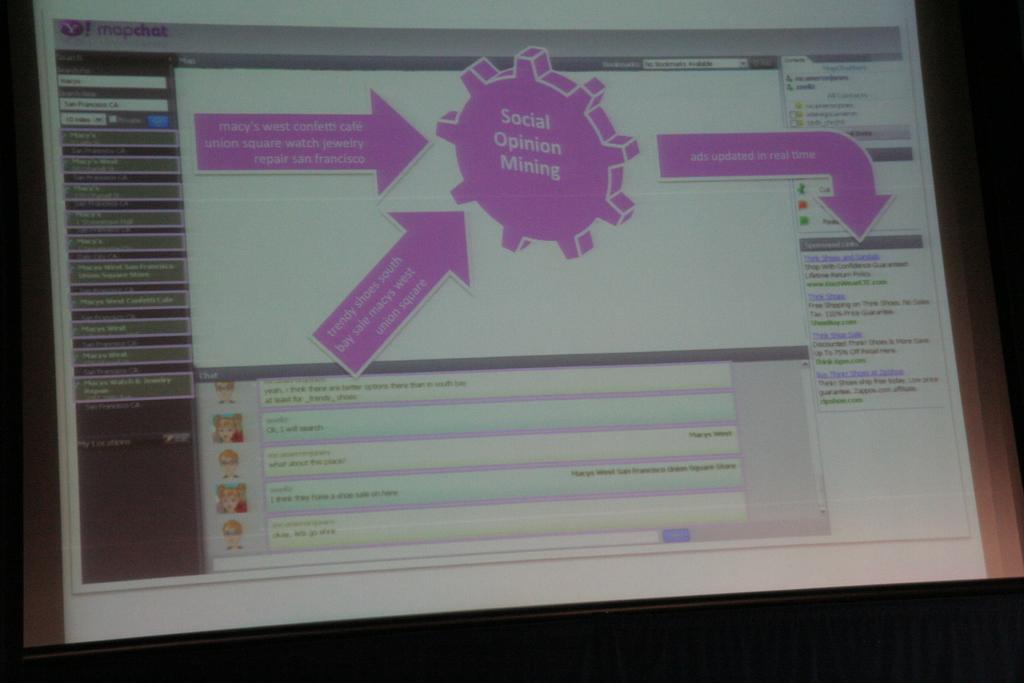Provide a one-sentence caption for the provided image. A screen is showing the website mapchat that has a social opinion mining chart. 